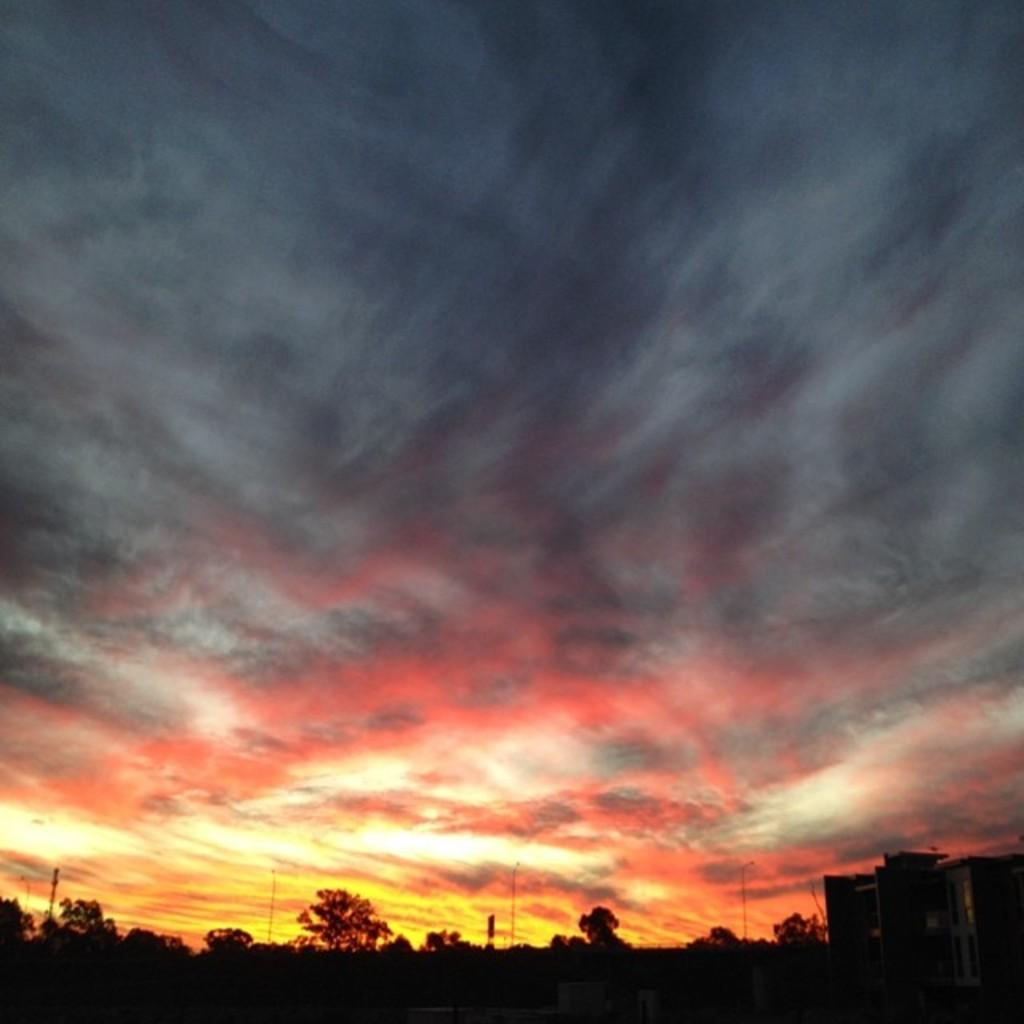What type of vegetation can be seen in the image? There are trees in the image. What colors are present in the sky in the image? The sky has yellow, red, and black colors in the image. Where is the bottle placed in the image? There is no bottle present in the image. What type of tent can be seen in the image? There is no tent present in the image. 